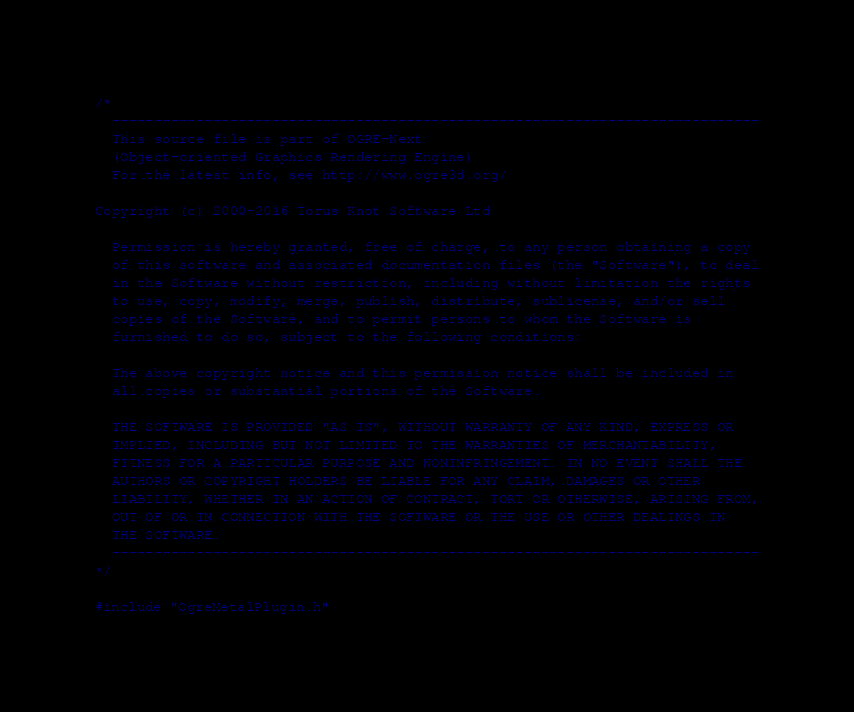Convert code to text. <code><loc_0><loc_0><loc_500><loc_500><_ObjectiveC_>/*
  -----------------------------------------------------------------------------
  This source file is part of OGRE-Next
  (Object-oriented Graphics Rendering Engine)
  For the latest info, see http://www.ogre3d.org/

Copyright (c) 2000-2016 Torus Knot Software Ltd

  Permission is hereby granted, free of charge, to any person obtaining a copy
  of this software and associated documentation files (the "Software"), to deal
  in the Software without restriction, including without limitation the rights
  to use, copy, modify, merge, publish, distribute, sublicense, and/or sell
  copies of the Software, and to permit persons to whom the Software is
  furnished to do so, subject to the following conditions:

  The above copyright notice and this permission notice shall be included in
  all copies or substantial portions of the Software.

  THE SOFTWARE IS PROVIDED "AS IS", WITHOUT WARRANTY OF ANY KIND, EXPRESS OR
  IMPLIED, INCLUDING BUT NOT LIMITED TO THE WARRANTIES OF MERCHANTABILITY,
  FITNESS FOR A PARTICULAR PURPOSE AND NONINFRINGEMENT. IN NO EVENT SHALL THE
  AUTHORS OR COPYRIGHT HOLDERS BE LIABLE FOR ANY CLAIM, DAMAGES OR OTHER
  LIABILITY, WHETHER IN AN ACTION OF CONTRACT, TORT OR OTHERWISE, ARISING FROM,
  OUT OF OR IN CONNECTION WITH THE SOFTWARE OR THE USE OR OTHER DEALINGS IN
  THE SOFTWARE.
  -----------------------------------------------------------------------------
*/

#include "OgreMetalPlugin.h"
</code> 